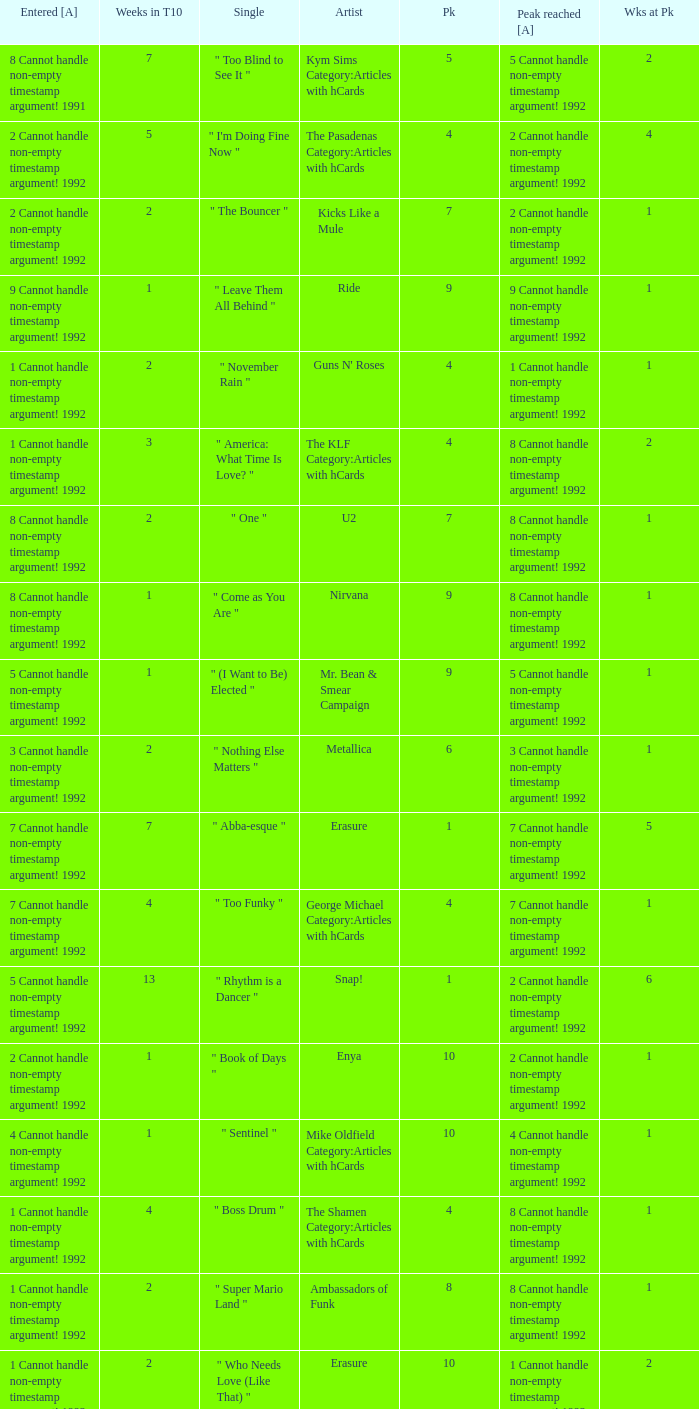What was the peak reached for a single with 4 weeks in the top 10 and entered in 7 cannot handle non-empty timestamp argument! 1992? 7 Cannot handle non-empty timestamp argument! 1992. 